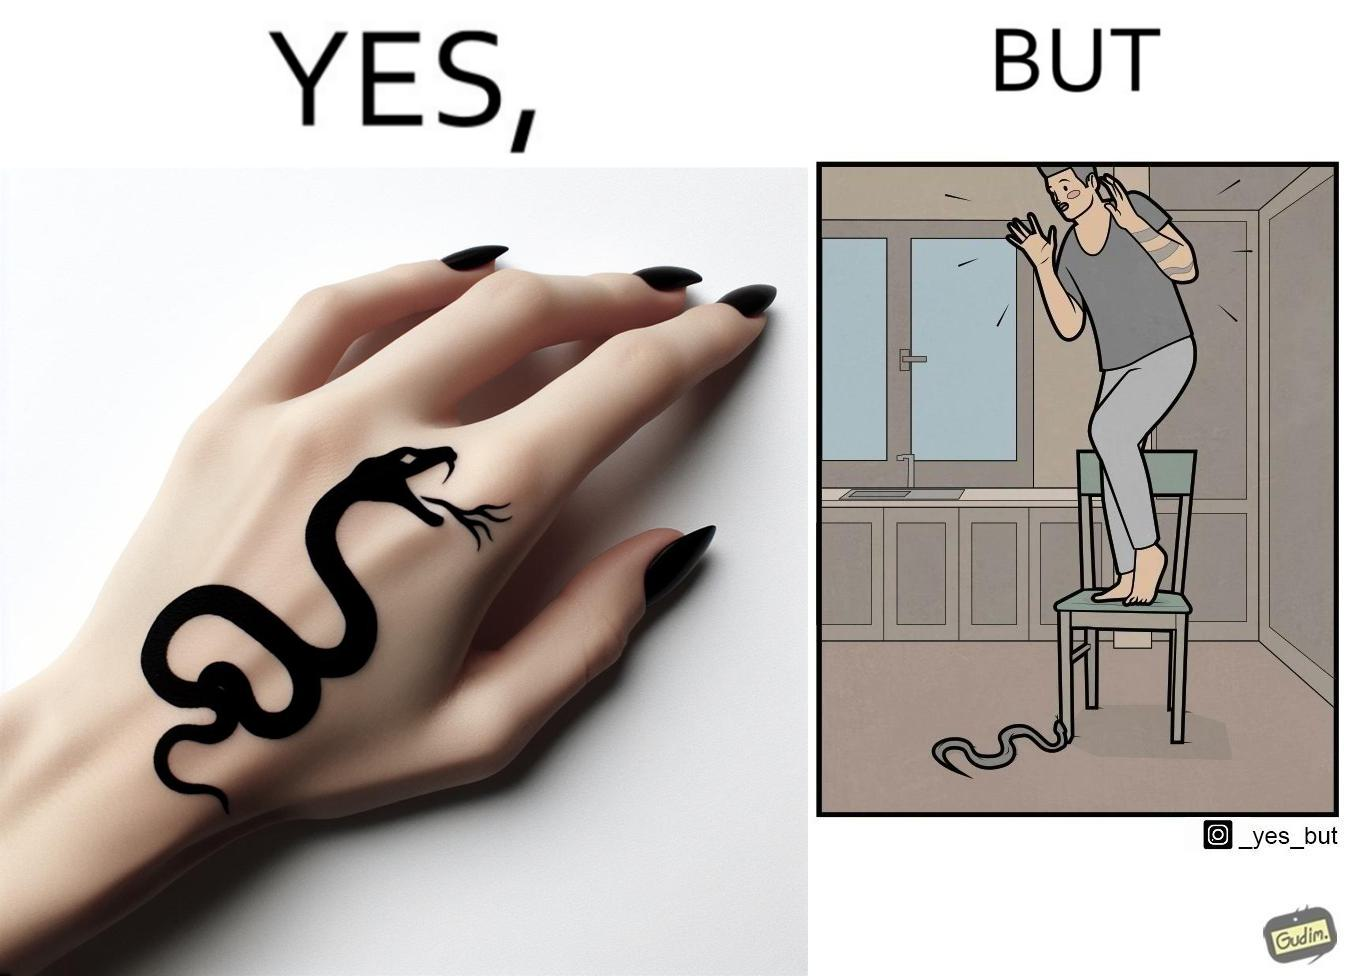What is shown in this image? The image is ironic, because in the first image the tattoo of a snake on someone's hand may give us a hint about how powerful or brave the person can be who is having this tattoo but in the second image the person with same tattoo is seen frightened due to a snake in his house 